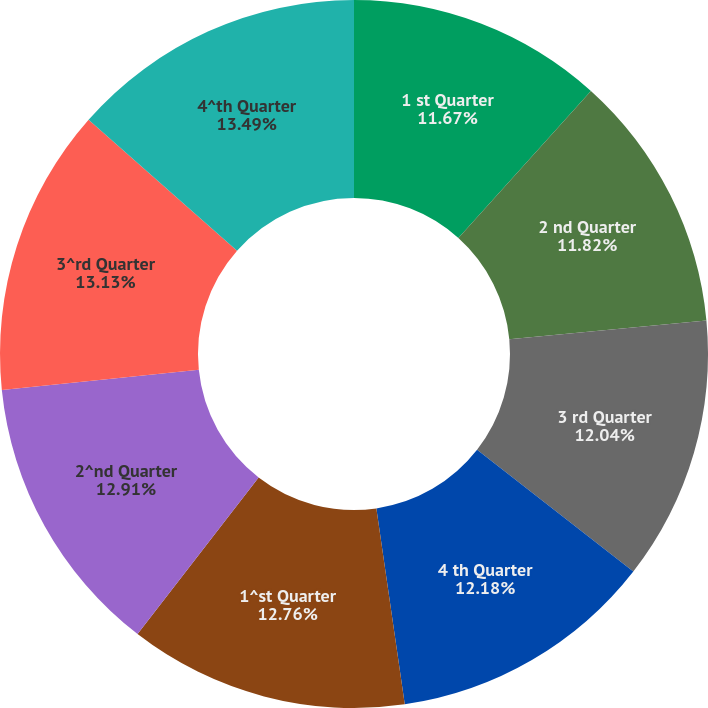Convert chart to OTSL. <chart><loc_0><loc_0><loc_500><loc_500><pie_chart><fcel>1 st Quarter<fcel>2 nd Quarter<fcel>3 rd Quarter<fcel>4 th Quarter<fcel>1^st Quarter<fcel>2^nd Quarter<fcel>3^rd Quarter<fcel>4^th Quarter<nl><fcel>11.67%<fcel>11.82%<fcel>12.04%<fcel>12.18%<fcel>12.76%<fcel>12.91%<fcel>13.13%<fcel>13.49%<nl></chart> 